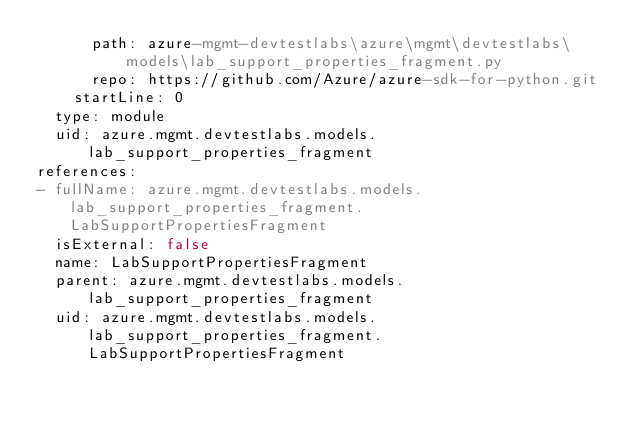<code> <loc_0><loc_0><loc_500><loc_500><_YAML_>      path: azure-mgmt-devtestlabs\azure\mgmt\devtestlabs\models\lab_support_properties_fragment.py
      repo: https://github.com/Azure/azure-sdk-for-python.git
    startLine: 0
  type: module
  uid: azure.mgmt.devtestlabs.models.lab_support_properties_fragment
references:
- fullName: azure.mgmt.devtestlabs.models.lab_support_properties_fragment.LabSupportPropertiesFragment
  isExternal: false
  name: LabSupportPropertiesFragment
  parent: azure.mgmt.devtestlabs.models.lab_support_properties_fragment
  uid: azure.mgmt.devtestlabs.models.lab_support_properties_fragment.LabSupportPropertiesFragment
</code> 